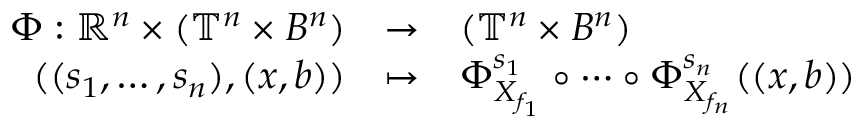Convert formula to latex. <formula><loc_0><loc_0><loc_500><loc_500>\begin{array} { r c l } { \Phi \colon \mathbb { R } ^ { n } \times ( \mathbb { T } ^ { n } \times B ^ { n } ) } & { \rightarrow } & { ( \mathbb { T } ^ { n } \times B ^ { n } ) } \\ { ( ( s _ { 1 } , \dots , s _ { n } ) , ( x , b ) ) } & { \mapsto } & { \Phi _ { X _ { f _ { 1 } } } ^ { s _ { 1 } } \circ \cdots \circ \Phi _ { X _ { f _ { n } } } ^ { s _ { n } } ( ( x , b ) ) } \end{array}</formula> 